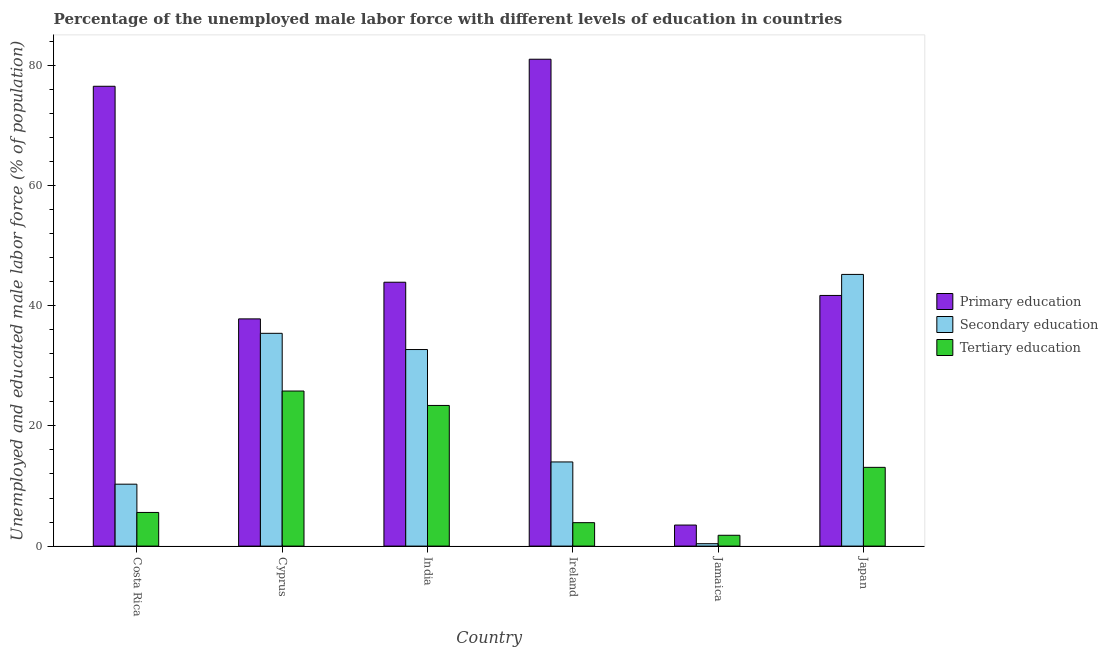How many different coloured bars are there?
Ensure brevity in your answer.  3. How many groups of bars are there?
Provide a short and direct response. 6. Are the number of bars per tick equal to the number of legend labels?
Provide a succinct answer. Yes. Are the number of bars on each tick of the X-axis equal?
Offer a terse response. Yes. How many bars are there on the 3rd tick from the right?
Give a very brief answer. 3. What is the label of the 1st group of bars from the left?
Provide a succinct answer. Costa Rica. In how many cases, is the number of bars for a given country not equal to the number of legend labels?
Provide a short and direct response. 0. What is the percentage of male labor force who received secondary education in Ireland?
Ensure brevity in your answer.  14. Across all countries, what is the maximum percentage of male labor force who received secondary education?
Your answer should be compact. 45.2. Across all countries, what is the minimum percentage of male labor force who received secondary education?
Offer a terse response. 0.4. In which country was the percentage of male labor force who received tertiary education minimum?
Provide a short and direct response. Jamaica. What is the total percentage of male labor force who received secondary education in the graph?
Your answer should be compact. 138. What is the difference between the percentage of male labor force who received secondary education in Costa Rica and that in Jamaica?
Your response must be concise. 9.9. What is the difference between the percentage of male labor force who received primary education in Jamaica and the percentage of male labor force who received secondary education in Ireland?
Offer a terse response. -10.5. What is the average percentage of male labor force who received primary education per country?
Provide a short and direct response. 47.4. What is the difference between the percentage of male labor force who received primary education and percentage of male labor force who received secondary education in India?
Give a very brief answer. 11.2. What is the ratio of the percentage of male labor force who received tertiary education in India to that in Japan?
Ensure brevity in your answer.  1.79. Is the percentage of male labor force who received primary education in Cyprus less than that in Ireland?
Give a very brief answer. Yes. What is the difference between the highest and the second highest percentage of male labor force who received primary education?
Your answer should be very brief. 4.5. What is the difference between the highest and the lowest percentage of male labor force who received secondary education?
Your answer should be compact. 44.8. In how many countries, is the percentage of male labor force who received primary education greater than the average percentage of male labor force who received primary education taken over all countries?
Your answer should be compact. 2. Is the sum of the percentage of male labor force who received primary education in Cyprus and India greater than the maximum percentage of male labor force who received secondary education across all countries?
Offer a terse response. Yes. What does the 3rd bar from the left in Japan represents?
Keep it short and to the point. Tertiary education. What does the 2nd bar from the right in Cyprus represents?
Offer a terse response. Secondary education. What is the difference between two consecutive major ticks on the Y-axis?
Offer a very short reply. 20. Does the graph contain grids?
Your response must be concise. No. Where does the legend appear in the graph?
Provide a succinct answer. Center right. How many legend labels are there?
Your answer should be compact. 3. How are the legend labels stacked?
Keep it short and to the point. Vertical. What is the title of the graph?
Provide a short and direct response. Percentage of the unemployed male labor force with different levels of education in countries. What is the label or title of the X-axis?
Give a very brief answer. Country. What is the label or title of the Y-axis?
Give a very brief answer. Unemployed and educated male labor force (% of population). What is the Unemployed and educated male labor force (% of population) of Primary education in Costa Rica?
Your answer should be very brief. 76.5. What is the Unemployed and educated male labor force (% of population) of Secondary education in Costa Rica?
Your response must be concise. 10.3. What is the Unemployed and educated male labor force (% of population) of Tertiary education in Costa Rica?
Your response must be concise. 5.6. What is the Unemployed and educated male labor force (% of population) in Primary education in Cyprus?
Ensure brevity in your answer.  37.8. What is the Unemployed and educated male labor force (% of population) in Secondary education in Cyprus?
Provide a short and direct response. 35.4. What is the Unemployed and educated male labor force (% of population) in Tertiary education in Cyprus?
Provide a succinct answer. 25.8. What is the Unemployed and educated male labor force (% of population) of Primary education in India?
Keep it short and to the point. 43.9. What is the Unemployed and educated male labor force (% of population) of Secondary education in India?
Your response must be concise. 32.7. What is the Unemployed and educated male labor force (% of population) in Tertiary education in India?
Your answer should be very brief. 23.4. What is the Unemployed and educated male labor force (% of population) of Secondary education in Ireland?
Your response must be concise. 14. What is the Unemployed and educated male labor force (% of population) in Tertiary education in Ireland?
Make the answer very short. 3.9. What is the Unemployed and educated male labor force (% of population) in Secondary education in Jamaica?
Make the answer very short. 0.4. What is the Unemployed and educated male labor force (% of population) in Tertiary education in Jamaica?
Your response must be concise. 1.8. What is the Unemployed and educated male labor force (% of population) of Primary education in Japan?
Your answer should be very brief. 41.7. What is the Unemployed and educated male labor force (% of population) of Secondary education in Japan?
Provide a succinct answer. 45.2. What is the Unemployed and educated male labor force (% of population) in Tertiary education in Japan?
Ensure brevity in your answer.  13.1. Across all countries, what is the maximum Unemployed and educated male labor force (% of population) in Primary education?
Offer a very short reply. 81. Across all countries, what is the maximum Unemployed and educated male labor force (% of population) in Secondary education?
Provide a short and direct response. 45.2. Across all countries, what is the maximum Unemployed and educated male labor force (% of population) of Tertiary education?
Offer a very short reply. 25.8. Across all countries, what is the minimum Unemployed and educated male labor force (% of population) of Primary education?
Keep it short and to the point. 3.5. Across all countries, what is the minimum Unemployed and educated male labor force (% of population) in Secondary education?
Provide a succinct answer. 0.4. Across all countries, what is the minimum Unemployed and educated male labor force (% of population) in Tertiary education?
Ensure brevity in your answer.  1.8. What is the total Unemployed and educated male labor force (% of population) of Primary education in the graph?
Your response must be concise. 284.4. What is the total Unemployed and educated male labor force (% of population) of Secondary education in the graph?
Your answer should be very brief. 138. What is the total Unemployed and educated male labor force (% of population) in Tertiary education in the graph?
Your response must be concise. 73.6. What is the difference between the Unemployed and educated male labor force (% of population) in Primary education in Costa Rica and that in Cyprus?
Make the answer very short. 38.7. What is the difference between the Unemployed and educated male labor force (% of population) of Secondary education in Costa Rica and that in Cyprus?
Your answer should be compact. -25.1. What is the difference between the Unemployed and educated male labor force (% of population) in Tertiary education in Costa Rica and that in Cyprus?
Keep it short and to the point. -20.2. What is the difference between the Unemployed and educated male labor force (% of population) in Primary education in Costa Rica and that in India?
Offer a terse response. 32.6. What is the difference between the Unemployed and educated male labor force (% of population) of Secondary education in Costa Rica and that in India?
Ensure brevity in your answer.  -22.4. What is the difference between the Unemployed and educated male labor force (% of population) of Tertiary education in Costa Rica and that in India?
Offer a very short reply. -17.8. What is the difference between the Unemployed and educated male labor force (% of population) of Tertiary education in Costa Rica and that in Ireland?
Offer a terse response. 1.7. What is the difference between the Unemployed and educated male labor force (% of population) in Primary education in Costa Rica and that in Jamaica?
Your answer should be very brief. 73. What is the difference between the Unemployed and educated male labor force (% of population) in Tertiary education in Costa Rica and that in Jamaica?
Offer a very short reply. 3.8. What is the difference between the Unemployed and educated male labor force (% of population) of Primary education in Costa Rica and that in Japan?
Make the answer very short. 34.8. What is the difference between the Unemployed and educated male labor force (% of population) in Secondary education in Costa Rica and that in Japan?
Give a very brief answer. -34.9. What is the difference between the Unemployed and educated male labor force (% of population) in Secondary education in Cyprus and that in India?
Offer a terse response. 2.7. What is the difference between the Unemployed and educated male labor force (% of population) in Primary education in Cyprus and that in Ireland?
Keep it short and to the point. -43.2. What is the difference between the Unemployed and educated male labor force (% of population) in Secondary education in Cyprus and that in Ireland?
Keep it short and to the point. 21.4. What is the difference between the Unemployed and educated male labor force (% of population) in Tertiary education in Cyprus and that in Ireland?
Offer a terse response. 21.9. What is the difference between the Unemployed and educated male labor force (% of population) in Primary education in Cyprus and that in Jamaica?
Offer a very short reply. 34.3. What is the difference between the Unemployed and educated male labor force (% of population) in Tertiary education in Cyprus and that in Jamaica?
Provide a succinct answer. 24. What is the difference between the Unemployed and educated male labor force (% of population) of Primary education in Cyprus and that in Japan?
Your answer should be very brief. -3.9. What is the difference between the Unemployed and educated male labor force (% of population) of Primary education in India and that in Ireland?
Keep it short and to the point. -37.1. What is the difference between the Unemployed and educated male labor force (% of population) of Secondary education in India and that in Ireland?
Make the answer very short. 18.7. What is the difference between the Unemployed and educated male labor force (% of population) of Tertiary education in India and that in Ireland?
Provide a short and direct response. 19.5. What is the difference between the Unemployed and educated male labor force (% of population) in Primary education in India and that in Jamaica?
Provide a succinct answer. 40.4. What is the difference between the Unemployed and educated male labor force (% of population) of Secondary education in India and that in Jamaica?
Make the answer very short. 32.3. What is the difference between the Unemployed and educated male labor force (% of population) of Tertiary education in India and that in Jamaica?
Make the answer very short. 21.6. What is the difference between the Unemployed and educated male labor force (% of population) in Primary education in India and that in Japan?
Your response must be concise. 2.2. What is the difference between the Unemployed and educated male labor force (% of population) in Secondary education in India and that in Japan?
Provide a succinct answer. -12.5. What is the difference between the Unemployed and educated male labor force (% of population) of Tertiary education in India and that in Japan?
Offer a very short reply. 10.3. What is the difference between the Unemployed and educated male labor force (% of population) of Primary education in Ireland and that in Jamaica?
Offer a very short reply. 77.5. What is the difference between the Unemployed and educated male labor force (% of population) of Primary education in Ireland and that in Japan?
Give a very brief answer. 39.3. What is the difference between the Unemployed and educated male labor force (% of population) in Secondary education in Ireland and that in Japan?
Your answer should be very brief. -31.2. What is the difference between the Unemployed and educated male labor force (% of population) in Primary education in Jamaica and that in Japan?
Give a very brief answer. -38.2. What is the difference between the Unemployed and educated male labor force (% of population) of Secondary education in Jamaica and that in Japan?
Give a very brief answer. -44.8. What is the difference between the Unemployed and educated male labor force (% of population) in Tertiary education in Jamaica and that in Japan?
Provide a short and direct response. -11.3. What is the difference between the Unemployed and educated male labor force (% of population) in Primary education in Costa Rica and the Unemployed and educated male labor force (% of population) in Secondary education in Cyprus?
Provide a short and direct response. 41.1. What is the difference between the Unemployed and educated male labor force (% of population) of Primary education in Costa Rica and the Unemployed and educated male labor force (% of population) of Tertiary education in Cyprus?
Your response must be concise. 50.7. What is the difference between the Unemployed and educated male labor force (% of population) in Secondary education in Costa Rica and the Unemployed and educated male labor force (% of population) in Tertiary education in Cyprus?
Offer a terse response. -15.5. What is the difference between the Unemployed and educated male labor force (% of population) in Primary education in Costa Rica and the Unemployed and educated male labor force (% of population) in Secondary education in India?
Ensure brevity in your answer.  43.8. What is the difference between the Unemployed and educated male labor force (% of population) in Primary education in Costa Rica and the Unemployed and educated male labor force (% of population) in Tertiary education in India?
Your answer should be compact. 53.1. What is the difference between the Unemployed and educated male labor force (% of population) in Primary education in Costa Rica and the Unemployed and educated male labor force (% of population) in Secondary education in Ireland?
Make the answer very short. 62.5. What is the difference between the Unemployed and educated male labor force (% of population) of Primary education in Costa Rica and the Unemployed and educated male labor force (% of population) of Tertiary education in Ireland?
Give a very brief answer. 72.6. What is the difference between the Unemployed and educated male labor force (% of population) of Primary education in Costa Rica and the Unemployed and educated male labor force (% of population) of Secondary education in Jamaica?
Provide a succinct answer. 76.1. What is the difference between the Unemployed and educated male labor force (% of population) in Primary education in Costa Rica and the Unemployed and educated male labor force (% of population) in Tertiary education in Jamaica?
Your answer should be compact. 74.7. What is the difference between the Unemployed and educated male labor force (% of population) in Primary education in Costa Rica and the Unemployed and educated male labor force (% of population) in Secondary education in Japan?
Make the answer very short. 31.3. What is the difference between the Unemployed and educated male labor force (% of population) in Primary education in Costa Rica and the Unemployed and educated male labor force (% of population) in Tertiary education in Japan?
Offer a terse response. 63.4. What is the difference between the Unemployed and educated male labor force (% of population) of Secondary education in Costa Rica and the Unemployed and educated male labor force (% of population) of Tertiary education in Japan?
Your answer should be compact. -2.8. What is the difference between the Unemployed and educated male labor force (% of population) in Primary education in Cyprus and the Unemployed and educated male labor force (% of population) in Secondary education in India?
Give a very brief answer. 5.1. What is the difference between the Unemployed and educated male labor force (% of population) of Primary education in Cyprus and the Unemployed and educated male labor force (% of population) of Tertiary education in India?
Make the answer very short. 14.4. What is the difference between the Unemployed and educated male labor force (% of population) in Primary education in Cyprus and the Unemployed and educated male labor force (% of population) in Secondary education in Ireland?
Offer a very short reply. 23.8. What is the difference between the Unemployed and educated male labor force (% of population) in Primary education in Cyprus and the Unemployed and educated male labor force (% of population) in Tertiary education in Ireland?
Your answer should be compact. 33.9. What is the difference between the Unemployed and educated male labor force (% of population) in Secondary education in Cyprus and the Unemployed and educated male labor force (% of population) in Tertiary education in Ireland?
Keep it short and to the point. 31.5. What is the difference between the Unemployed and educated male labor force (% of population) in Primary education in Cyprus and the Unemployed and educated male labor force (% of population) in Secondary education in Jamaica?
Ensure brevity in your answer.  37.4. What is the difference between the Unemployed and educated male labor force (% of population) of Secondary education in Cyprus and the Unemployed and educated male labor force (% of population) of Tertiary education in Jamaica?
Keep it short and to the point. 33.6. What is the difference between the Unemployed and educated male labor force (% of population) of Primary education in Cyprus and the Unemployed and educated male labor force (% of population) of Tertiary education in Japan?
Your answer should be very brief. 24.7. What is the difference between the Unemployed and educated male labor force (% of population) of Secondary education in Cyprus and the Unemployed and educated male labor force (% of population) of Tertiary education in Japan?
Ensure brevity in your answer.  22.3. What is the difference between the Unemployed and educated male labor force (% of population) of Primary education in India and the Unemployed and educated male labor force (% of population) of Secondary education in Ireland?
Make the answer very short. 29.9. What is the difference between the Unemployed and educated male labor force (% of population) of Secondary education in India and the Unemployed and educated male labor force (% of population) of Tertiary education in Ireland?
Offer a very short reply. 28.8. What is the difference between the Unemployed and educated male labor force (% of population) in Primary education in India and the Unemployed and educated male labor force (% of population) in Secondary education in Jamaica?
Ensure brevity in your answer.  43.5. What is the difference between the Unemployed and educated male labor force (% of population) in Primary education in India and the Unemployed and educated male labor force (% of population) in Tertiary education in Jamaica?
Offer a very short reply. 42.1. What is the difference between the Unemployed and educated male labor force (% of population) of Secondary education in India and the Unemployed and educated male labor force (% of population) of Tertiary education in Jamaica?
Your answer should be very brief. 30.9. What is the difference between the Unemployed and educated male labor force (% of population) in Primary education in India and the Unemployed and educated male labor force (% of population) in Tertiary education in Japan?
Keep it short and to the point. 30.8. What is the difference between the Unemployed and educated male labor force (% of population) of Secondary education in India and the Unemployed and educated male labor force (% of population) of Tertiary education in Japan?
Your answer should be very brief. 19.6. What is the difference between the Unemployed and educated male labor force (% of population) in Primary education in Ireland and the Unemployed and educated male labor force (% of population) in Secondary education in Jamaica?
Your response must be concise. 80.6. What is the difference between the Unemployed and educated male labor force (% of population) of Primary education in Ireland and the Unemployed and educated male labor force (% of population) of Tertiary education in Jamaica?
Your response must be concise. 79.2. What is the difference between the Unemployed and educated male labor force (% of population) in Primary education in Ireland and the Unemployed and educated male labor force (% of population) in Secondary education in Japan?
Your response must be concise. 35.8. What is the difference between the Unemployed and educated male labor force (% of population) of Primary education in Ireland and the Unemployed and educated male labor force (% of population) of Tertiary education in Japan?
Make the answer very short. 67.9. What is the difference between the Unemployed and educated male labor force (% of population) of Primary education in Jamaica and the Unemployed and educated male labor force (% of population) of Secondary education in Japan?
Your answer should be very brief. -41.7. What is the difference between the Unemployed and educated male labor force (% of population) in Primary education in Jamaica and the Unemployed and educated male labor force (% of population) in Tertiary education in Japan?
Ensure brevity in your answer.  -9.6. What is the difference between the Unemployed and educated male labor force (% of population) of Secondary education in Jamaica and the Unemployed and educated male labor force (% of population) of Tertiary education in Japan?
Ensure brevity in your answer.  -12.7. What is the average Unemployed and educated male labor force (% of population) of Primary education per country?
Give a very brief answer. 47.4. What is the average Unemployed and educated male labor force (% of population) of Secondary education per country?
Your response must be concise. 23. What is the average Unemployed and educated male labor force (% of population) in Tertiary education per country?
Offer a very short reply. 12.27. What is the difference between the Unemployed and educated male labor force (% of population) in Primary education and Unemployed and educated male labor force (% of population) in Secondary education in Costa Rica?
Offer a very short reply. 66.2. What is the difference between the Unemployed and educated male labor force (% of population) of Primary education and Unemployed and educated male labor force (% of population) of Tertiary education in Costa Rica?
Provide a succinct answer. 70.9. What is the difference between the Unemployed and educated male labor force (% of population) in Primary education and Unemployed and educated male labor force (% of population) in Secondary education in Cyprus?
Your answer should be compact. 2.4. What is the difference between the Unemployed and educated male labor force (% of population) of Secondary education and Unemployed and educated male labor force (% of population) of Tertiary education in Cyprus?
Give a very brief answer. 9.6. What is the difference between the Unemployed and educated male labor force (% of population) of Primary education and Unemployed and educated male labor force (% of population) of Tertiary education in India?
Your response must be concise. 20.5. What is the difference between the Unemployed and educated male labor force (% of population) of Secondary education and Unemployed and educated male labor force (% of population) of Tertiary education in India?
Keep it short and to the point. 9.3. What is the difference between the Unemployed and educated male labor force (% of population) in Primary education and Unemployed and educated male labor force (% of population) in Secondary education in Ireland?
Provide a succinct answer. 67. What is the difference between the Unemployed and educated male labor force (% of population) of Primary education and Unemployed and educated male labor force (% of population) of Tertiary education in Ireland?
Offer a very short reply. 77.1. What is the difference between the Unemployed and educated male labor force (% of population) in Primary education and Unemployed and educated male labor force (% of population) in Secondary education in Jamaica?
Provide a succinct answer. 3.1. What is the difference between the Unemployed and educated male labor force (% of population) in Primary education and Unemployed and educated male labor force (% of population) in Tertiary education in Japan?
Make the answer very short. 28.6. What is the difference between the Unemployed and educated male labor force (% of population) of Secondary education and Unemployed and educated male labor force (% of population) of Tertiary education in Japan?
Your answer should be compact. 32.1. What is the ratio of the Unemployed and educated male labor force (% of population) in Primary education in Costa Rica to that in Cyprus?
Provide a short and direct response. 2.02. What is the ratio of the Unemployed and educated male labor force (% of population) of Secondary education in Costa Rica to that in Cyprus?
Ensure brevity in your answer.  0.29. What is the ratio of the Unemployed and educated male labor force (% of population) of Tertiary education in Costa Rica to that in Cyprus?
Ensure brevity in your answer.  0.22. What is the ratio of the Unemployed and educated male labor force (% of population) of Primary education in Costa Rica to that in India?
Give a very brief answer. 1.74. What is the ratio of the Unemployed and educated male labor force (% of population) in Secondary education in Costa Rica to that in India?
Offer a very short reply. 0.32. What is the ratio of the Unemployed and educated male labor force (% of population) of Tertiary education in Costa Rica to that in India?
Ensure brevity in your answer.  0.24. What is the ratio of the Unemployed and educated male labor force (% of population) in Primary education in Costa Rica to that in Ireland?
Provide a succinct answer. 0.94. What is the ratio of the Unemployed and educated male labor force (% of population) in Secondary education in Costa Rica to that in Ireland?
Your response must be concise. 0.74. What is the ratio of the Unemployed and educated male labor force (% of population) in Tertiary education in Costa Rica to that in Ireland?
Give a very brief answer. 1.44. What is the ratio of the Unemployed and educated male labor force (% of population) of Primary education in Costa Rica to that in Jamaica?
Provide a short and direct response. 21.86. What is the ratio of the Unemployed and educated male labor force (% of population) of Secondary education in Costa Rica to that in Jamaica?
Your response must be concise. 25.75. What is the ratio of the Unemployed and educated male labor force (% of population) in Tertiary education in Costa Rica to that in Jamaica?
Provide a succinct answer. 3.11. What is the ratio of the Unemployed and educated male labor force (% of population) of Primary education in Costa Rica to that in Japan?
Offer a terse response. 1.83. What is the ratio of the Unemployed and educated male labor force (% of population) in Secondary education in Costa Rica to that in Japan?
Ensure brevity in your answer.  0.23. What is the ratio of the Unemployed and educated male labor force (% of population) in Tertiary education in Costa Rica to that in Japan?
Your answer should be very brief. 0.43. What is the ratio of the Unemployed and educated male labor force (% of population) of Primary education in Cyprus to that in India?
Offer a very short reply. 0.86. What is the ratio of the Unemployed and educated male labor force (% of population) of Secondary education in Cyprus to that in India?
Provide a short and direct response. 1.08. What is the ratio of the Unemployed and educated male labor force (% of population) in Tertiary education in Cyprus to that in India?
Your answer should be very brief. 1.1. What is the ratio of the Unemployed and educated male labor force (% of population) of Primary education in Cyprus to that in Ireland?
Make the answer very short. 0.47. What is the ratio of the Unemployed and educated male labor force (% of population) of Secondary education in Cyprus to that in Ireland?
Ensure brevity in your answer.  2.53. What is the ratio of the Unemployed and educated male labor force (% of population) in Tertiary education in Cyprus to that in Ireland?
Your response must be concise. 6.62. What is the ratio of the Unemployed and educated male labor force (% of population) in Primary education in Cyprus to that in Jamaica?
Provide a succinct answer. 10.8. What is the ratio of the Unemployed and educated male labor force (% of population) of Secondary education in Cyprus to that in Jamaica?
Provide a succinct answer. 88.5. What is the ratio of the Unemployed and educated male labor force (% of population) in Tertiary education in Cyprus to that in Jamaica?
Give a very brief answer. 14.33. What is the ratio of the Unemployed and educated male labor force (% of population) in Primary education in Cyprus to that in Japan?
Your answer should be compact. 0.91. What is the ratio of the Unemployed and educated male labor force (% of population) of Secondary education in Cyprus to that in Japan?
Your response must be concise. 0.78. What is the ratio of the Unemployed and educated male labor force (% of population) in Tertiary education in Cyprus to that in Japan?
Provide a succinct answer. 1.97. What is the ratio of the Unemployed and educated male labor force (% of population) of Primary education in India to that in Ireland?
Your answer should be very brief. 0.54. What is the ratio of the Unemployed and educated male labor force (% of population) of Secondary education in India to that in Ireland?
Offer a very short reply. 2.34. What is the ratio of the Unemployed and educated male labor force (% of population) in Tertiary education in India to that in Ireland?
Keep it short and to the point. 6. What is the ratio of the Unemployed and educated male labor force (% of population) in Primary education in India to that in Jamaica?
Keep it short and to the point. 12.54. What is the ratio of the Unemployed and educated male labor force (% of population) of Secondary education in India to that in Jamaica?
Ensure brevity in your answer.  81.75. What is the ratio of the Unemployed and educated male labor force (% of population) in Primary education in India to that in Japan?
Provide a succinct answer. 1.05. What is the ratio of the Unemployed and educated male labor force (% of population) in Secondary education in India to that in Japan?
Your response must be concise. 0.72. What is the ratio of the Unemployed and educated male labor force (% of population) of Tertiary education in India to that in Japan?
Your response must be concise. 1.79. What is the ratio of the Unemployed and educated male labor force (% of population) of Primary education in Ireland to that in Jamaica?
Offer a terse response. 23.14. What is the ratio of the Unemployed and educated male labor force (% of population) in Tertiary education in Ireland to that in Jamaica?
Ensure brevity in your answer.  2.17. What is the ratio of the Unemployed and educated male labor force (% of population) of Primary education in Ireland to that in Japan?
Give a very brief answer. 1.94. What is the ratio of the Unemployed and educated male labor force (% of population) of Secondary education in Ireland to that in Japan?
Your response must be concise. 0.31. What is the ratio of the Unemployed and educated male labor force (% of population) in Tertiary education in Ireland to that in Japan?
Your answer should be very brief. 0.3. What is the ratio of the Unemployed and educated male labor force (% of population) of Primary education in Jamaica to that in Japan?
Your answer should be very brief. 0.08. What is the ratio of the Unemployed and educated male labor force (% of population) of Secondary education in Jamaica to that in Japan?
Give a very brief answer. 0.01. What is the ratio of the Unemployed and educated male labor force (% of population) in Tertiary education in Jamaica to that in Japan?
Provide a succinct answer. 0.14. What is the difference between the highest and the second highest Unemployed and educated male labor force (% of population) of Primary education?
Keep it short and to the point. 4.5. What is the difference between the highest and the second highest Unemployed and educated male labor force (% of population) in Secondary education?
Your answer should be compact. 9.8. What is the difference between the highest and the second highest Unemployed and educated male labor force (% of population) in Tertiary education?
Offer a terse response. 2.4. What is the difference between the highest and the lowest Unemployed and educated male labor force (% of population) in Primary education?
Ensure brevity in your answer.  77.5. What is the difference between the highest and the lowest Unemployed and educated male labor force (% of population) of Secondary education?
Offer a terse response. 44.8. 